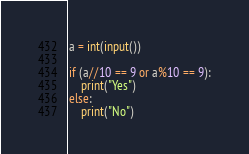<code> <loc_0><loc_0><loc_500><loc_500><_Python_>a = int(input())
 
if (a//10 == 9 or a%10 == 9):
    print("Yes")
else:
    print("No")</code> 